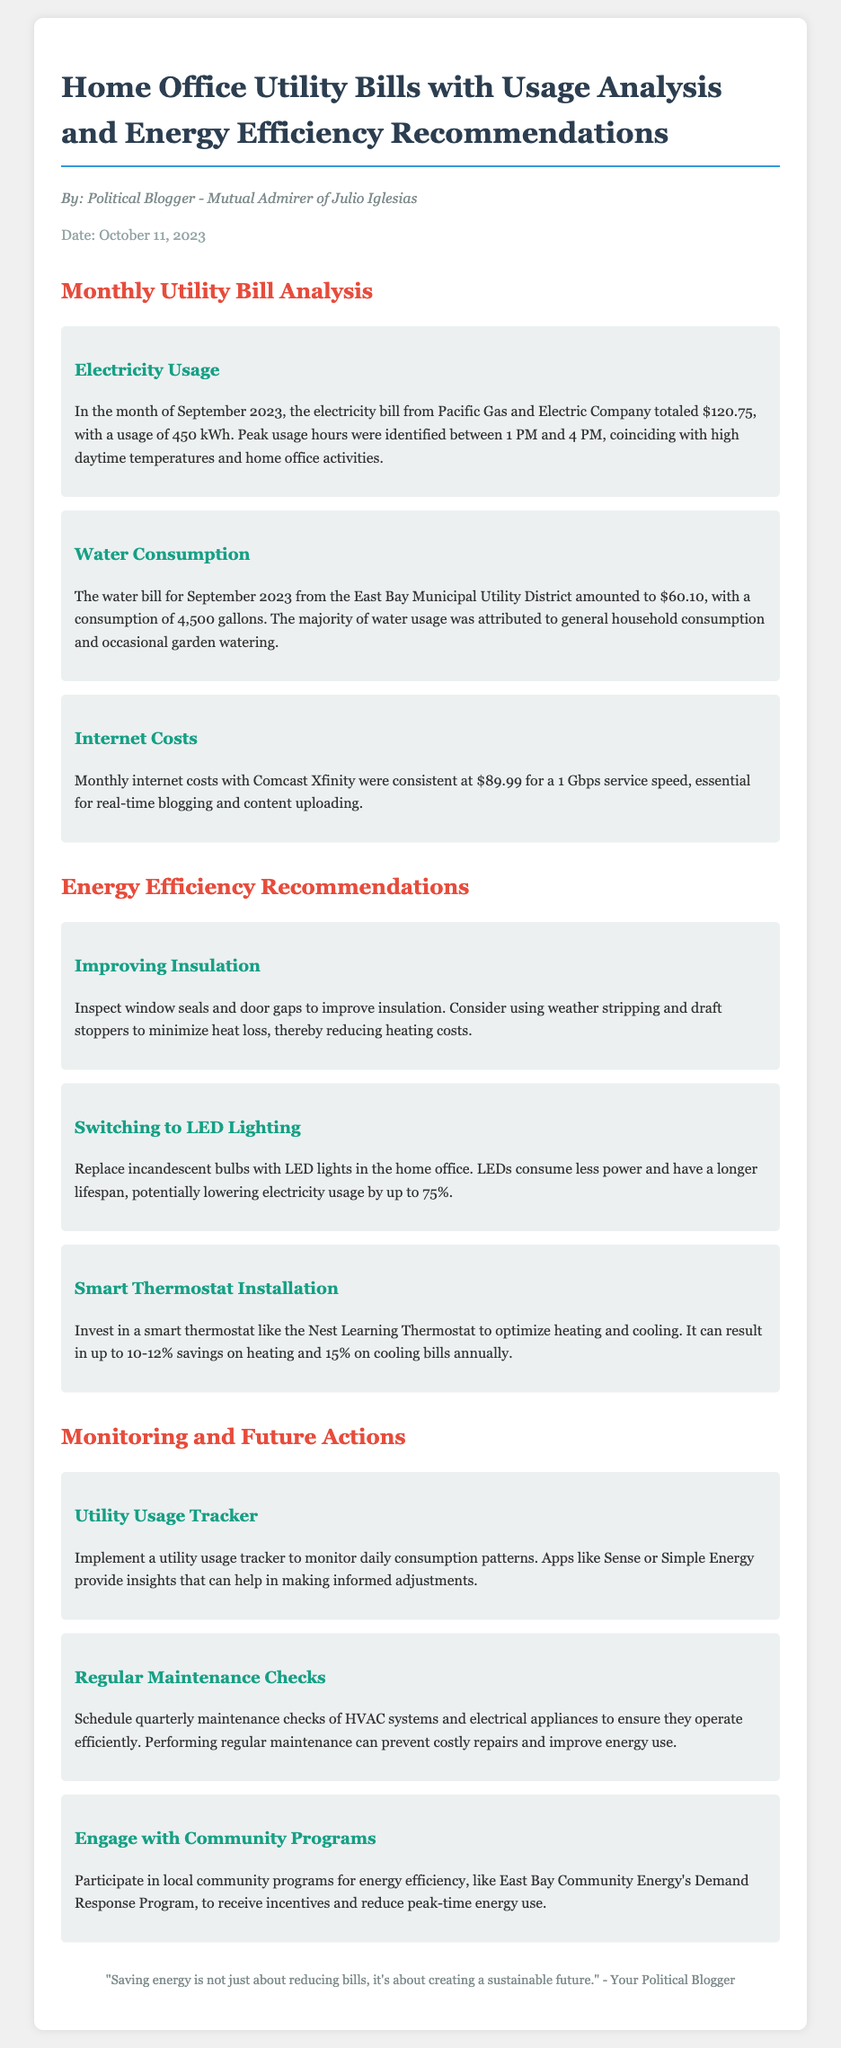what was the electricity bill for September 2023? The electricity bill from Pacific Gas and Electric Company for September 2023 totaled $120.75.
Answer: $120.75 how many gallons of water were consumed in September 2023? The water consumption for September 2023 was 4,500 gallons.
Answer: 4,500 gallons what is the monthly internet cost? The monthly internet costs with Comcast Xfinity were consistent at $89.99.
Answer: $89.99 what are the peak usage hours for electricity? Peak usage hours were identified between 1 PM and 4 PM.
Answer: 1 PM and 4 PM what is one recommendation for improving insulation? One recommendation is to inspect window seals and door gaps.
Answer: Inspect window seals and door gaps how much can a smart thermostat save on heating bills annually? A smart thermostat can result in up to 10-12% savings on heating bills annually.
Answer: 10-12% what is suggested to monitor daily consumption patterns? Implement a utility usage tracker is suggested to monitor daily consumption patterns.
Answer: Utility usage tracker what local community program is mentioned for energy efficiency? The East Bay Community Energy's Demand Response Program is mentioned.
Answer: East Bay Community Energy's Demand Response Program how often should maintenance checks be scheduled? Maintenance checks should be scheduled quarterly.
Answer: Quarterly 